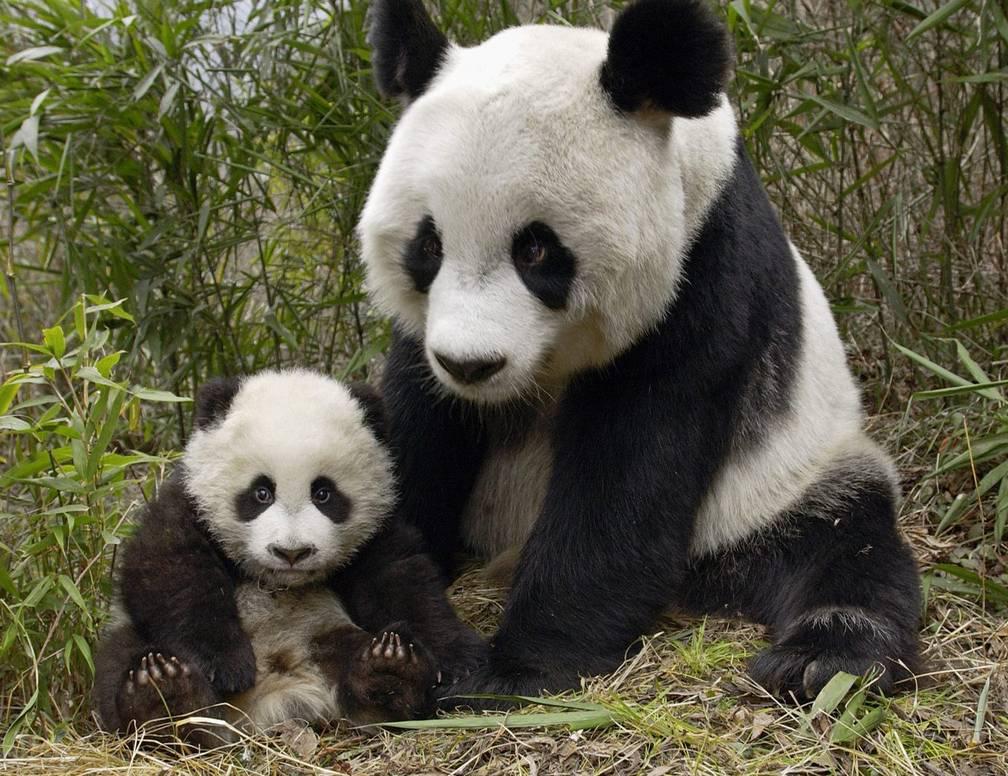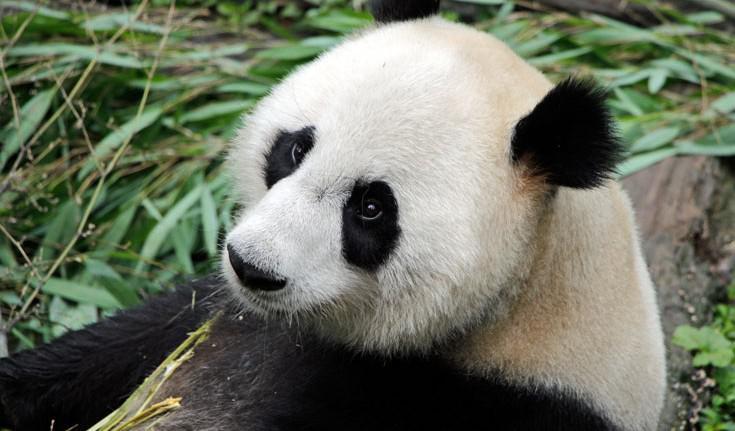The first image is the image on the left, the second image is the image on the right. Assess this claim about the two images: "A baby panda is resting on its mother's chest". Correct or not? Answer yes or no. No. 